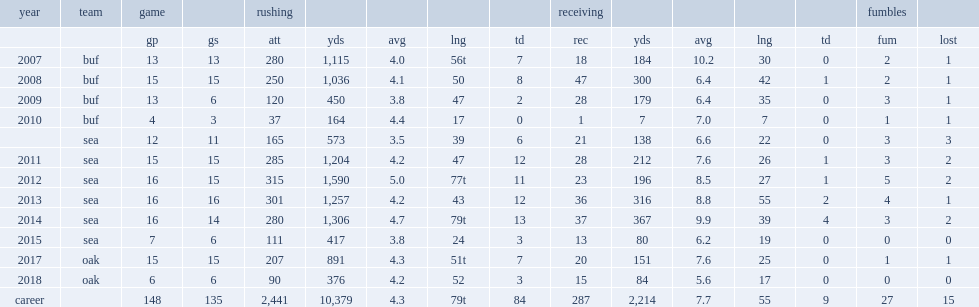How many yards did marshawn lynch for the seahawks in the 2013 season rush for? 1257.0. How many touchdowns did marshawn lynch for the seahawks in the 2013 season rush for? 12.0. How many rushing yards did marshawn lynch finish the rookie season with? 1115.0. How many touchdowns did marshawn lynch finish the rookie season with? 7.0. Could you parse the entire table as a dict? {'header': ['year', 'team', 'game', '', 'rushing', '', '', '', '', 'receiving', '', '', '', '', 'fumbles', ''], 'rows': [['', '', 'gp', 'gs', 'att', 'yds', 'avg', 'lng', 'td', 'rec', 'yds', 'avg', 'lng', 'td', 'fum', 'lost'], ['2007', 'buf', '13', '13', '280', '1,115', '4.0', '56t', '7', '18', '184', '10.2', '30', '0', '2', '1'], ['2008', 'buf', '15', '15', '250', '1,036', '4.1', '50', '8', '47', '300', '6.4', '42', '1', '2', '1'], ['2009', 'buf', '13', '6', '120', '450', '3.8', '47', '2', '28', '179', '6.4', '35', '0', '3', '1'], ['2010', 'buf', '4', '3', '37', '164', '4.4', '17', '0', '1', '7', '7.0', '7', '0', '1', '1'], ['', 'sea', '12', '11', '165', '573', '3.5', '39', '6', '21', '138', '6.6', '22', '0', '3', '3'], ['2011', 'sea', '15', '15', '285', '1,204', '4.2', '47', '12', '28', '212', '7.6', '26', '1', '3', '2'], ['2012', 'sea', '16', '15', '315', '1,590', '5.0', '77t', '11', '23', '196', '8.5', '27', '1', '5', '2'], ['2013', 'sea', '16', '16', '301', '1,257', '4.2', '43', '12', '36', '316', '8.8', '55', '2', '4', '1'], ['2014', 'sea', '16', '14', '280', '1,306', '4.7', '79t', '13', '37', '367', '9.9', '39', '4', '3', '2'], ['2015', 'sea', '7', '6', '111', '417', '3.8', '24', '3', '13', '80', '6.2', '19', '0', '0', '0'], ['2017', 'oak', '15', '15', '207', '891', '4.3', '51t', '7', '20', '151', '7.6', '25', '0', '1', '1'], ['2018', 'oak', '6', '6', '90', '376', '4.2', '52', '3', '15', '84', '5.6', '17', '0', '0', '0'], ['career', '', '148', '135', '2,441', '10,379', '4.3', '79t', '84', '287', '2,214', '7.7', '55', '9', '27', '15']]} 